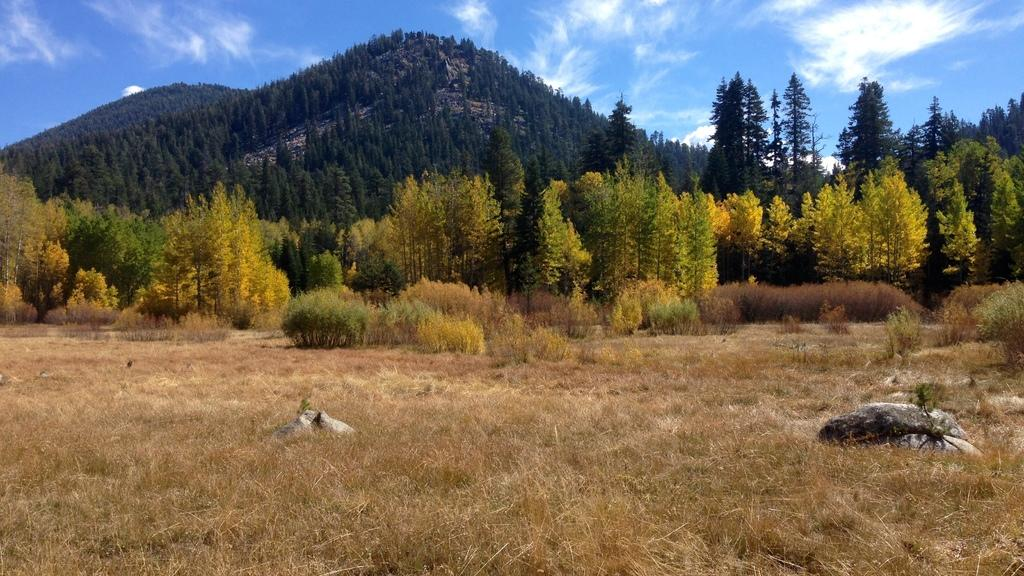What type of vegetation can be seen in the image? There is grass, plants, and trees visible in the image. What is the terrain like in the image? There is a hill visible in the background of the image. What can be seen in the sky in the image? The sky is visible in the background of the image. How many minutes does it take for the pear to grow in the image? There is no pear present in the image, so it is not possible to determine how long it would take for a pear to grow. 